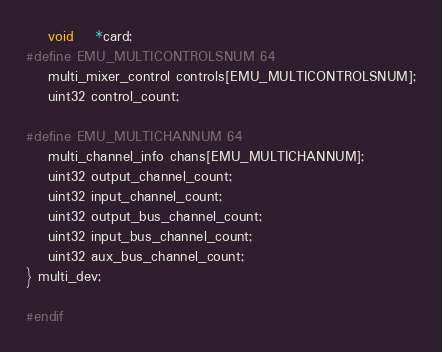Convert code to text. <code><loc_0><loc_0><loc_500><loc_500><_C_>	void	*card;
#define EMU_MULTICONTROLSNUM 64
	multi_mixer_control controls[EMU_MULTICONTROLSNUM];
	uint32 control_count;
	
#define EMU_MULTICHANNUM 64
	multi_channel_info chans[EMU_MULTICHANNUM];
	uint32 output_channel_count;
	uint32 input_channel_count;
	uint32 output_bus_channel_count;
	uint32 input_bus_channel_count;
	uint32 aux_bus_channel_count;
} multi_dev;

#endif
</code> 